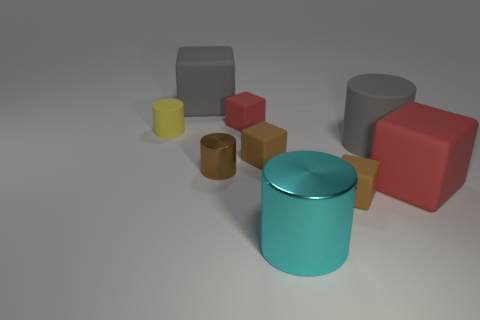Is the big gray cylinder made of the same material as the small red thing?
Ensure brevity in your answer.  Yes. Are there any big gray rubber objects behind the gray cylinder?
Provide a short and direct response. Yes. There is a red object on the right side of the small rubber thing that is right of the cyan object; what is its material?
Provide a short and direct response. Rubber. The brown shiny object that is the same shape as the yellow rubber thing is what size?
Provide a succinct answer. Small. What is the color of the cylinder that is both on the left side of the tiny red object and on the right side of the tiny yellow matte cylinder?
Provide a short and direct response. Brown. Do the red thing behind the yellow matte cylinder and the small yellow matte cylinder have the same size?
Provide a short and direct response. Yes. Is the material of the small brown cylinder the same as the large block that is on the left side of the small brown cylinder?
Make the answer very short. No. How many brown things are either metal balls or shiny cylinders?
Your answer should be compact. 1. Is there a big green matte thing?
Offer a very short reply. No. Is there a tiny cylinder in front of the big matte block that is to the left of the red rubber block behind the yellow matte cylinder?
Ensure brevity in your answer.  Yes. 